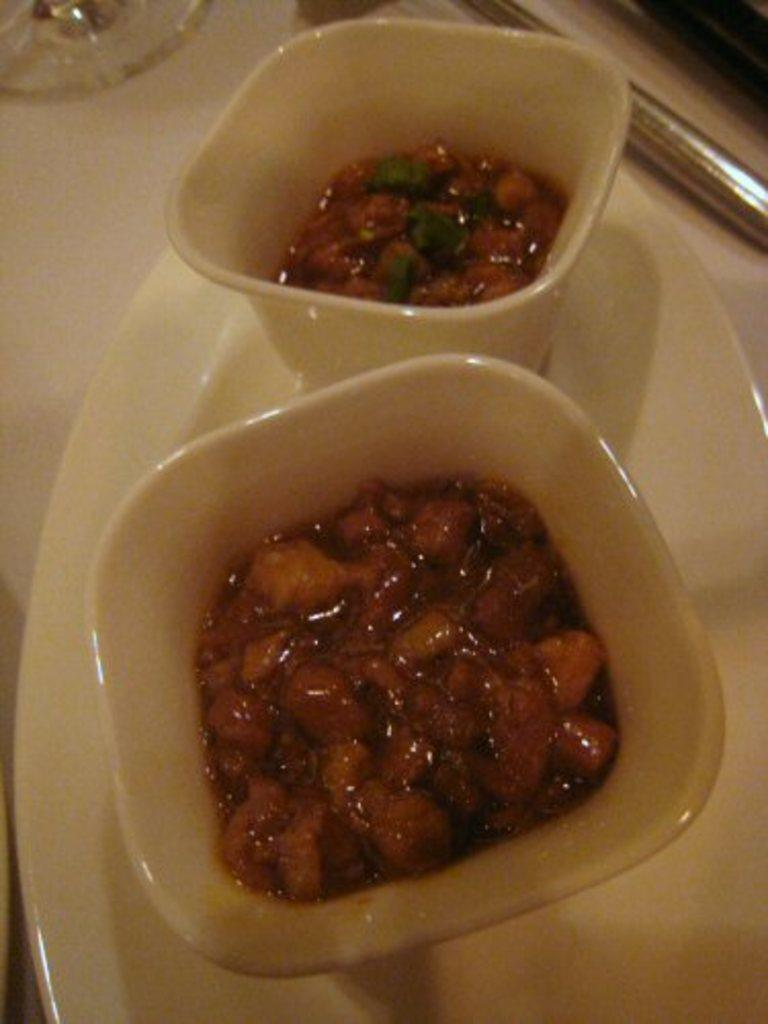What type of food items can be seen in the image? There are food items in bowls in the image. What else is present on the white color plate in the image? There are balls on the white color plate in the image. What other objects can be seen on a surface in the image? There are other objects on a surface in the image. What type of grass can be seen growing on the surface in the image? There is no grass present in the image; it features food items in bowls, balls on a white color plate, and other objects on a surface. 